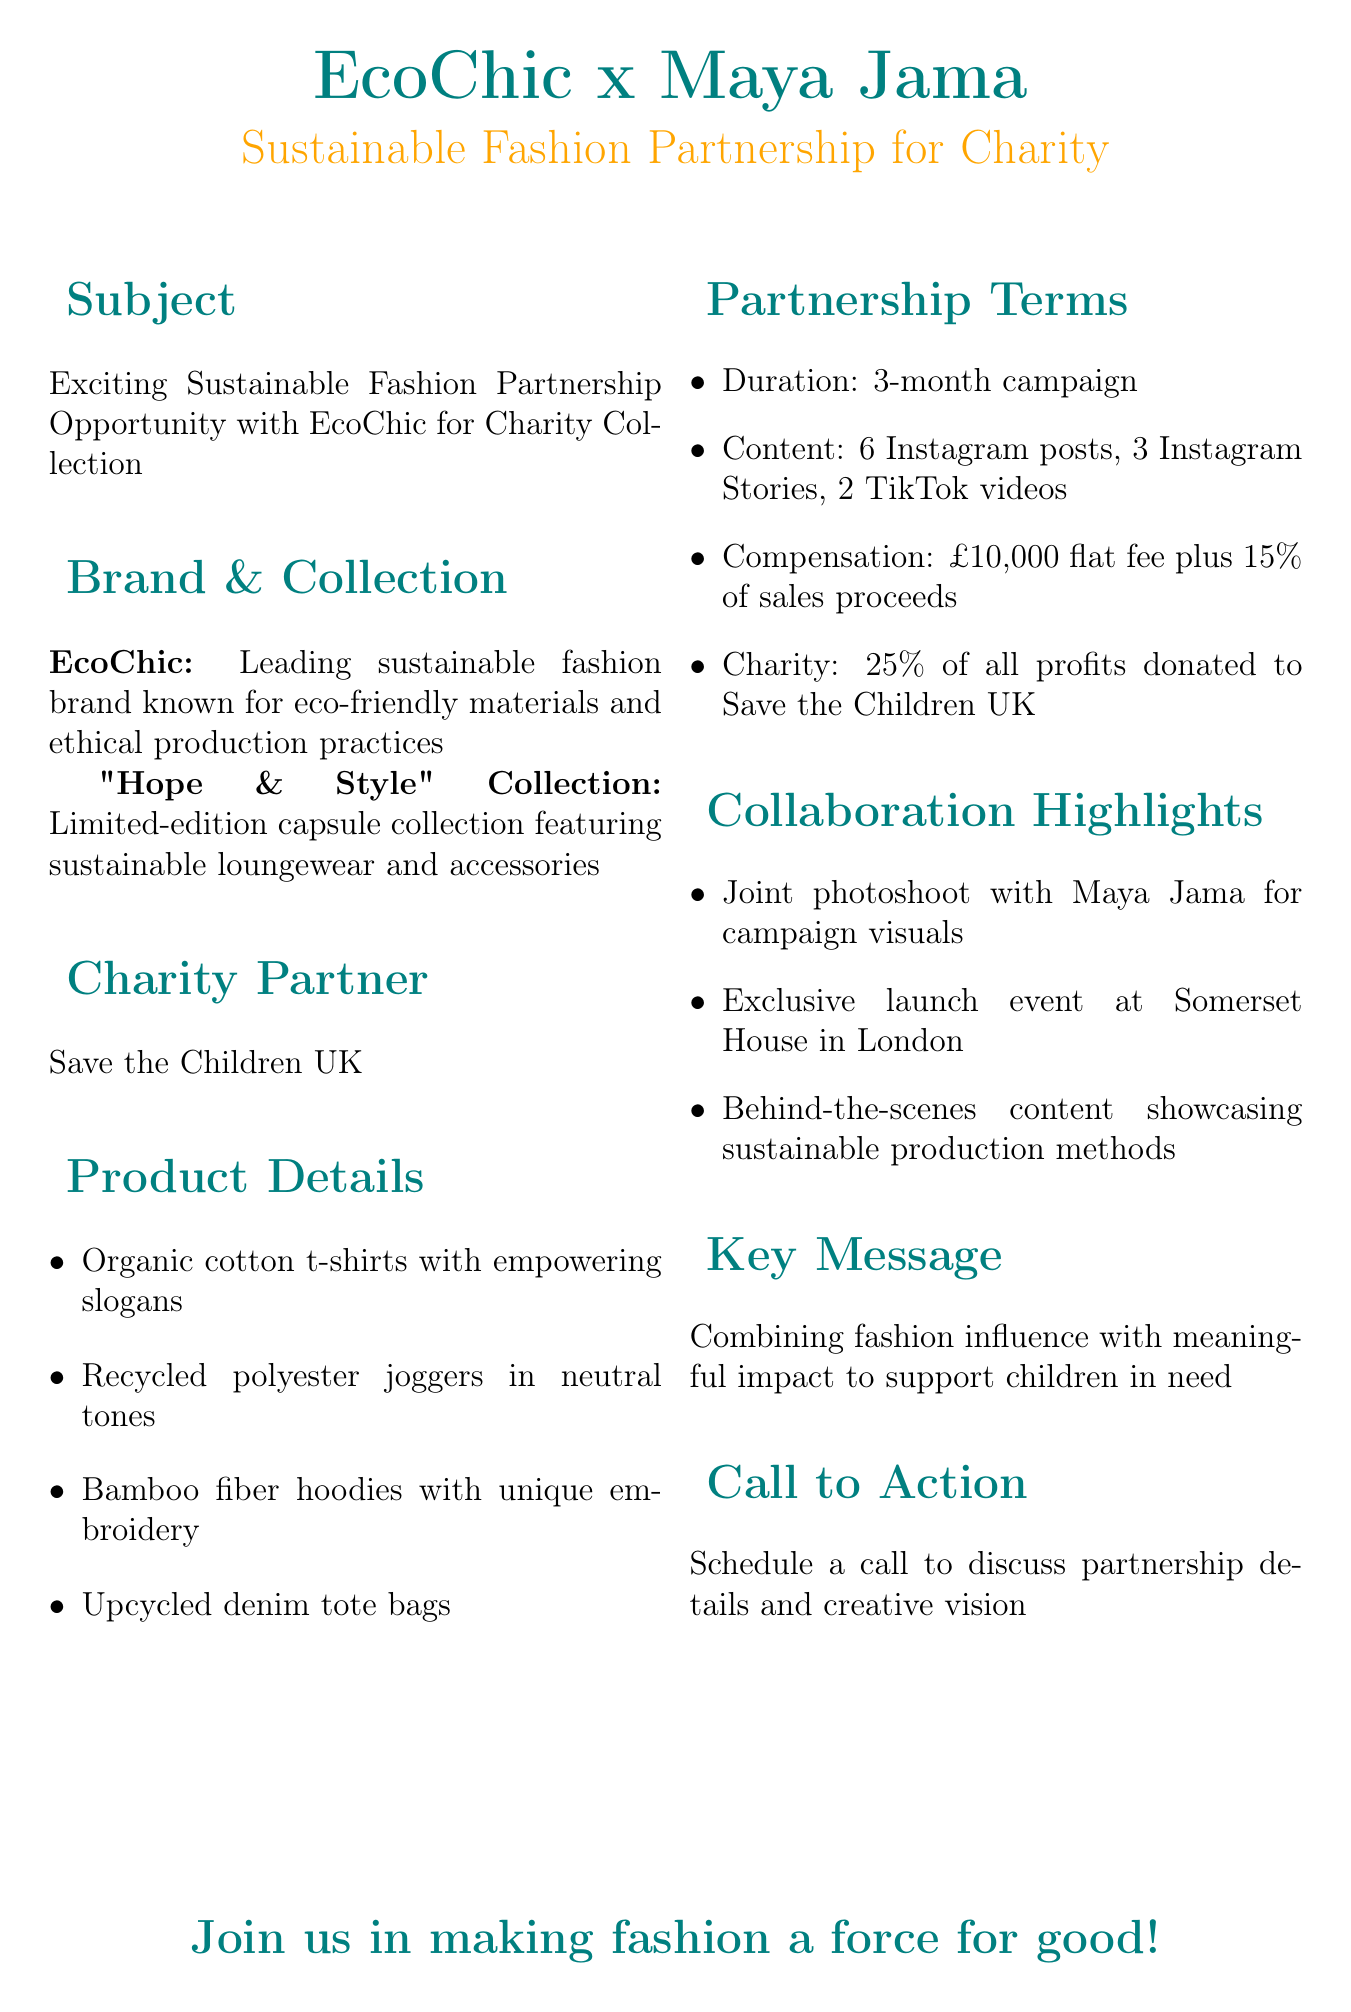What is the partnership duration? The partnership duration is specified in the document, which states a "3-month campaign."
Answer: 3-month campaign Who is the charity partner? The charity partner is explicitly mentioned in the email as "Save the Children UK."
Answer: Save the Children UK What is the flat fee compensation? The document outlines the compensation terms, which include a "£10,000 flat fee."
Answer: £10,000 flat fee What kind of products are included in the collection? The document lists specific products that are part of the collection, including "Organic cotton t-shirts with empowering slogans."
Answer: Organic cotton t-shirts with empowering slogans How much of the profits will be donated to charity? The email states that "25% of all profits" will be donated to the charity partner.
Answer: 25% of all profits What type of content is required for the campaign? The document outlines several types of content, including "6 Instagram posts, 3 Instagram Stories, 2 TikTok videos."
Answer: 6 Instagram posts, 3 Instagram Stories, 2 TikTok videos Who will participate in the joint photoshoot? It is specified that "Maya Jama" will participate in the joint photoshoot for campaign visuals.
Answer: Maya Jama What is the key message of the campaign? The document clearly states the key message as "Combining fashion influence with meaningful impact to support children in need."
Answer: Combining fashion influence with meaningful impact to support children in need 